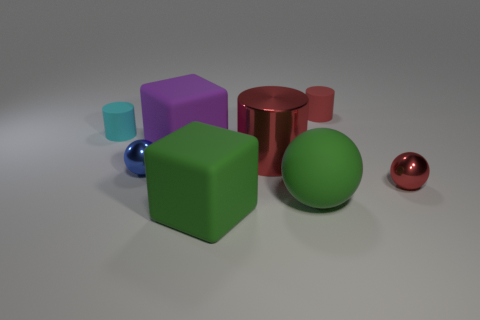Subtract all large cylinders. How many cylinders are left? 2 Add 2 tiny green matte cubes. How many objects exist? 10 Subtract all blue spheres. How many red cylinders are left? 2 Subtract 1 cylinders. How many cylinders are left? 2 Subtract all spheres. How many objects are left? 5 Subtract all small green metallic cylinders. Subtract all red cylinders. How many objects are left? 6 Add 3 cylinders. How many cylinders are left? 6 Add 7 small blue metal spheres. How many small blue metal spheres exist? 8 Subtract 0 purple spheres. How many objects are left? 8 Subtract all blue cylinders. Subtract all gray cubes. How many cylinders are left? 3 